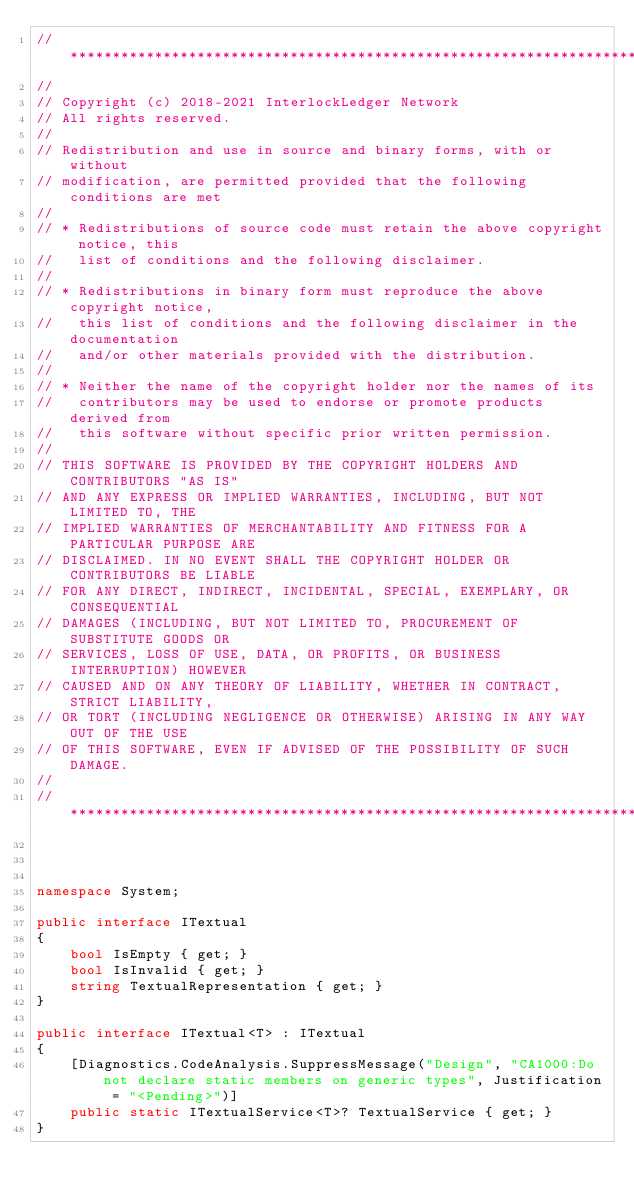<code> <loc_0><loc_0><loc_500><loc_500><_C#_>// ******************************************************************************************************************************
//
// Copyright (c) 2018-2021 InterlockLedger Network
// All rights reserved.
//
// Redistribution and use in source and binary forms, with or without
// modification, are permitted provided that the following conditions are met
//
// * Redistributions of source code must retain the above copyright notice, this
//   list of conditions and the following disclaimer.
//
// * Redistributions in binary form must reproduce the above copyright notice,
//   this list of conditions and the following disclaimer in the documentation
//   and/or other materials provided with the distribution.
//
// * Neither the name of the copyright holder nor the names of its
//   contributors may be used to endorse or promote products derived from
//   this software without specific prior written permission.
//
// THIS SOFTWARE IS PROVIDED BY THE COPYRIGHT HOLDERS AND CONTRIBUTORS "AS IS"
// AND ANY EXPRESS OR IMPLIED WARRANTIES, INCLUDING, BUT NOT LIMITED TO, THE
// IMPLIED WARRANTIES OF MERCHANTABILITY AND FITNESS FOR A PARTICULAR PURPOSE ARE
// DISCLAIMED. IN NO EVENT SHALL THE COPYRIGHT HOLDER OR CONTRIBUTORS BE LIABLE
// FOR ANY DIRECT, INDIRECT, INCIDENTAL, SPECIAL, EXEMPLARY, OR CONSEQUENTIAL
// DAMAGES (INCLUDING, BUT NOT LIMITED TO, PROCUREMENT OF SUBSTITUTE GOODS OR
// SERVICES, LOSS OF USE, DATA, OR PROFITS, OR BUSINESS INTERRUPTION) HOWEVER
// CAUSED AND ON ANY THEORY OF LIABILITY, WHETHER IN CONTRACT, STRICT LIABILITY,
// OR TORT (INCLUDING NEGLIGENCE OR OTHERWISE) ARISING IN ANY WAY OUT OF THE USE
// OF THIS SOFTWARE, EVEN IF ADVISED OF THE POSSIBILITY OF SUCH DAMAGE.
//
// ******************************************************************************************************************************



namespace System;

public interface ITextual
{
    bool IsEmpty { get; }
    bool IsInvalid { get; }
    string TextualRepresentation { get; }
}

public interface ITextual<T> : ITextual
{
    [Diagnostics.CodeAnalysis.SuppressMessage("Design", "CA1000:Do not declare static members on generic types", Justification = "<Pending>")]
    public static ITextualService<T>? TextualService { get; }
}</code> 